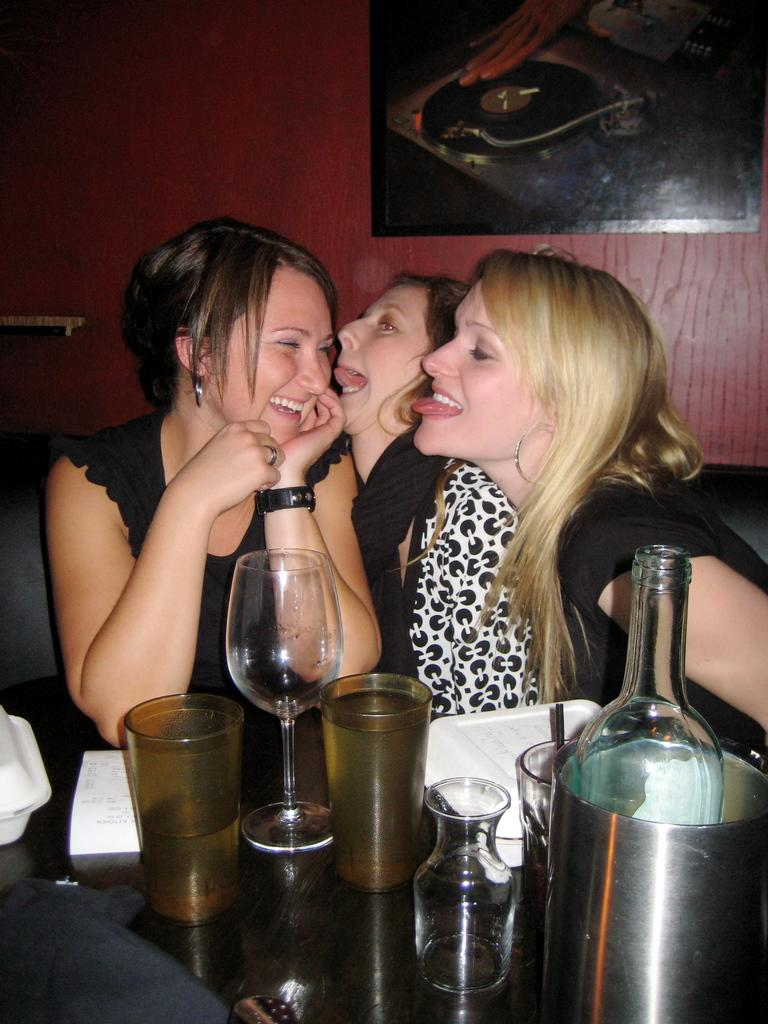How many people are sitting on the sofa in the image? There are three persons sitting on the sofa in the image. Can you describe the facial expression of one of the persons? One person is smiling. What objects can be seen on the table in the image? There are glasses, a jar, a tray, a paper, and a box on the table in the image. What can be seen in the background of the image? There is a wall and a frame in the background. What type of disease is affecting the person sitting on the left side of the sofa? There is no indication of any disease affecting any person in the image. 